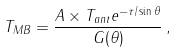Convert formula to latex. <formula><loc_0><loc_0><loc_500><loc_500>T _ { M B } = \frac { A \times T _ { a n t } e ^ { - \tau / \sin \theta } } { G ( \theta ) } \, ,</formula> 